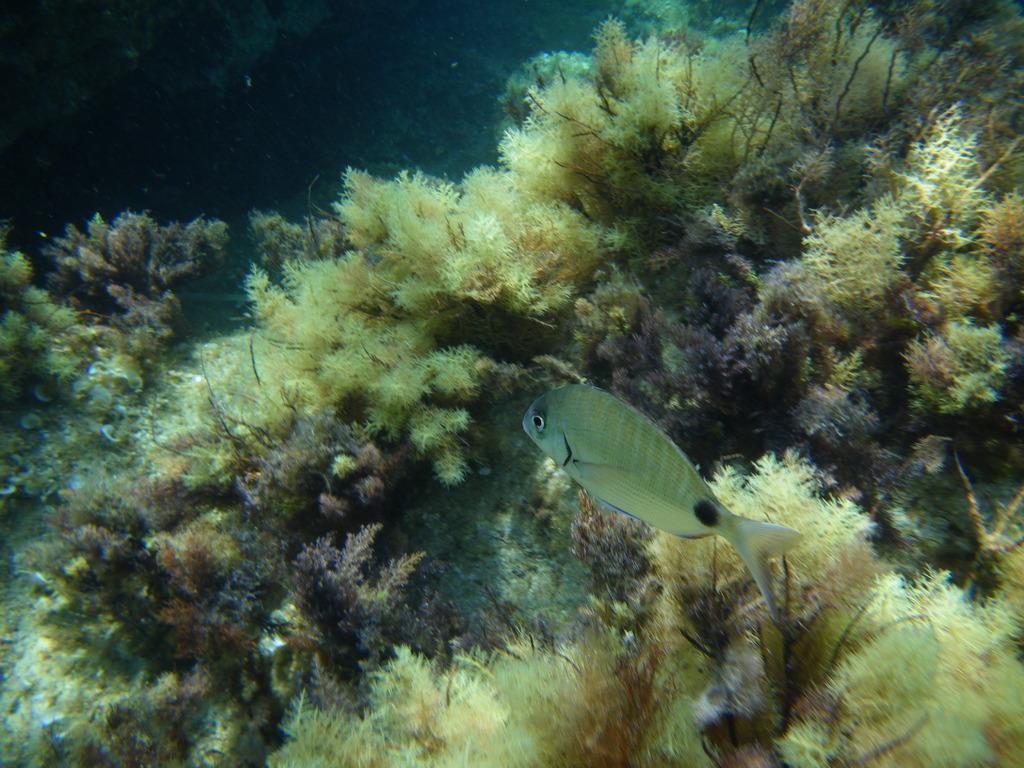In one or two sentences, can you explain what this image depicts? In the image we can see fish and water marine. 